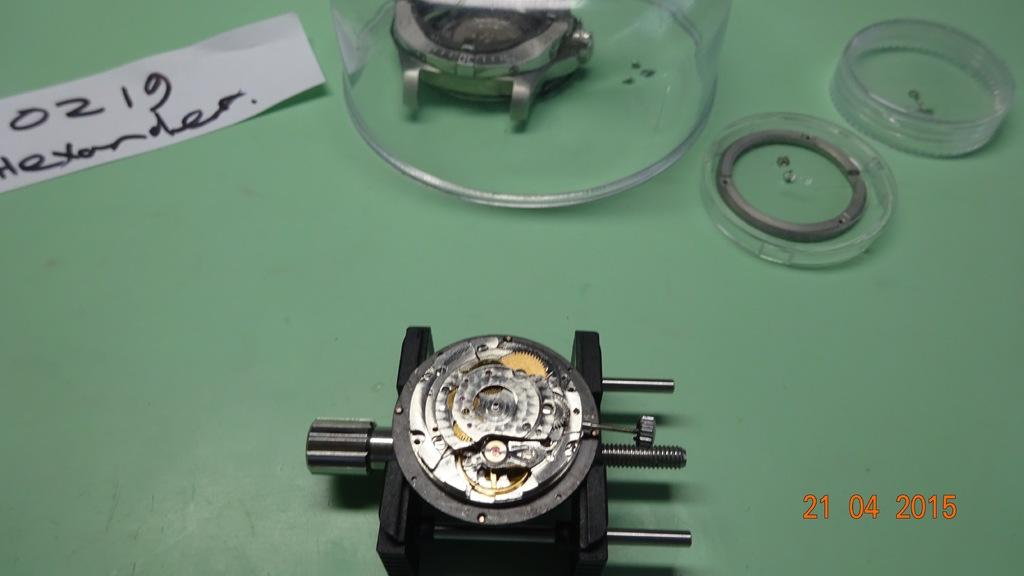Provide a one-sentence caption for the provided image. A dismantled watch movement is held in a vise and a white strip of paper above and to the left of it has 0219 Alexander written on it. 